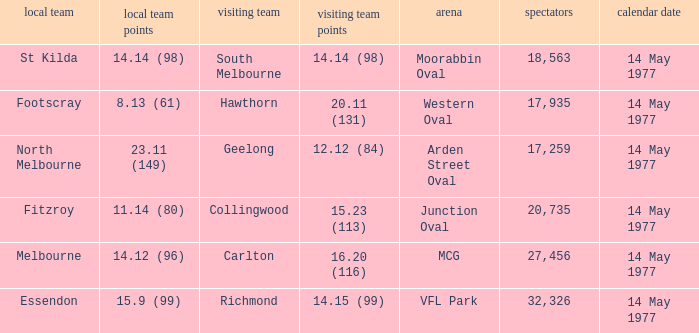I want to know the home team score of the away team of richmond that has a crowd more than 20,735 15.9 (99). 